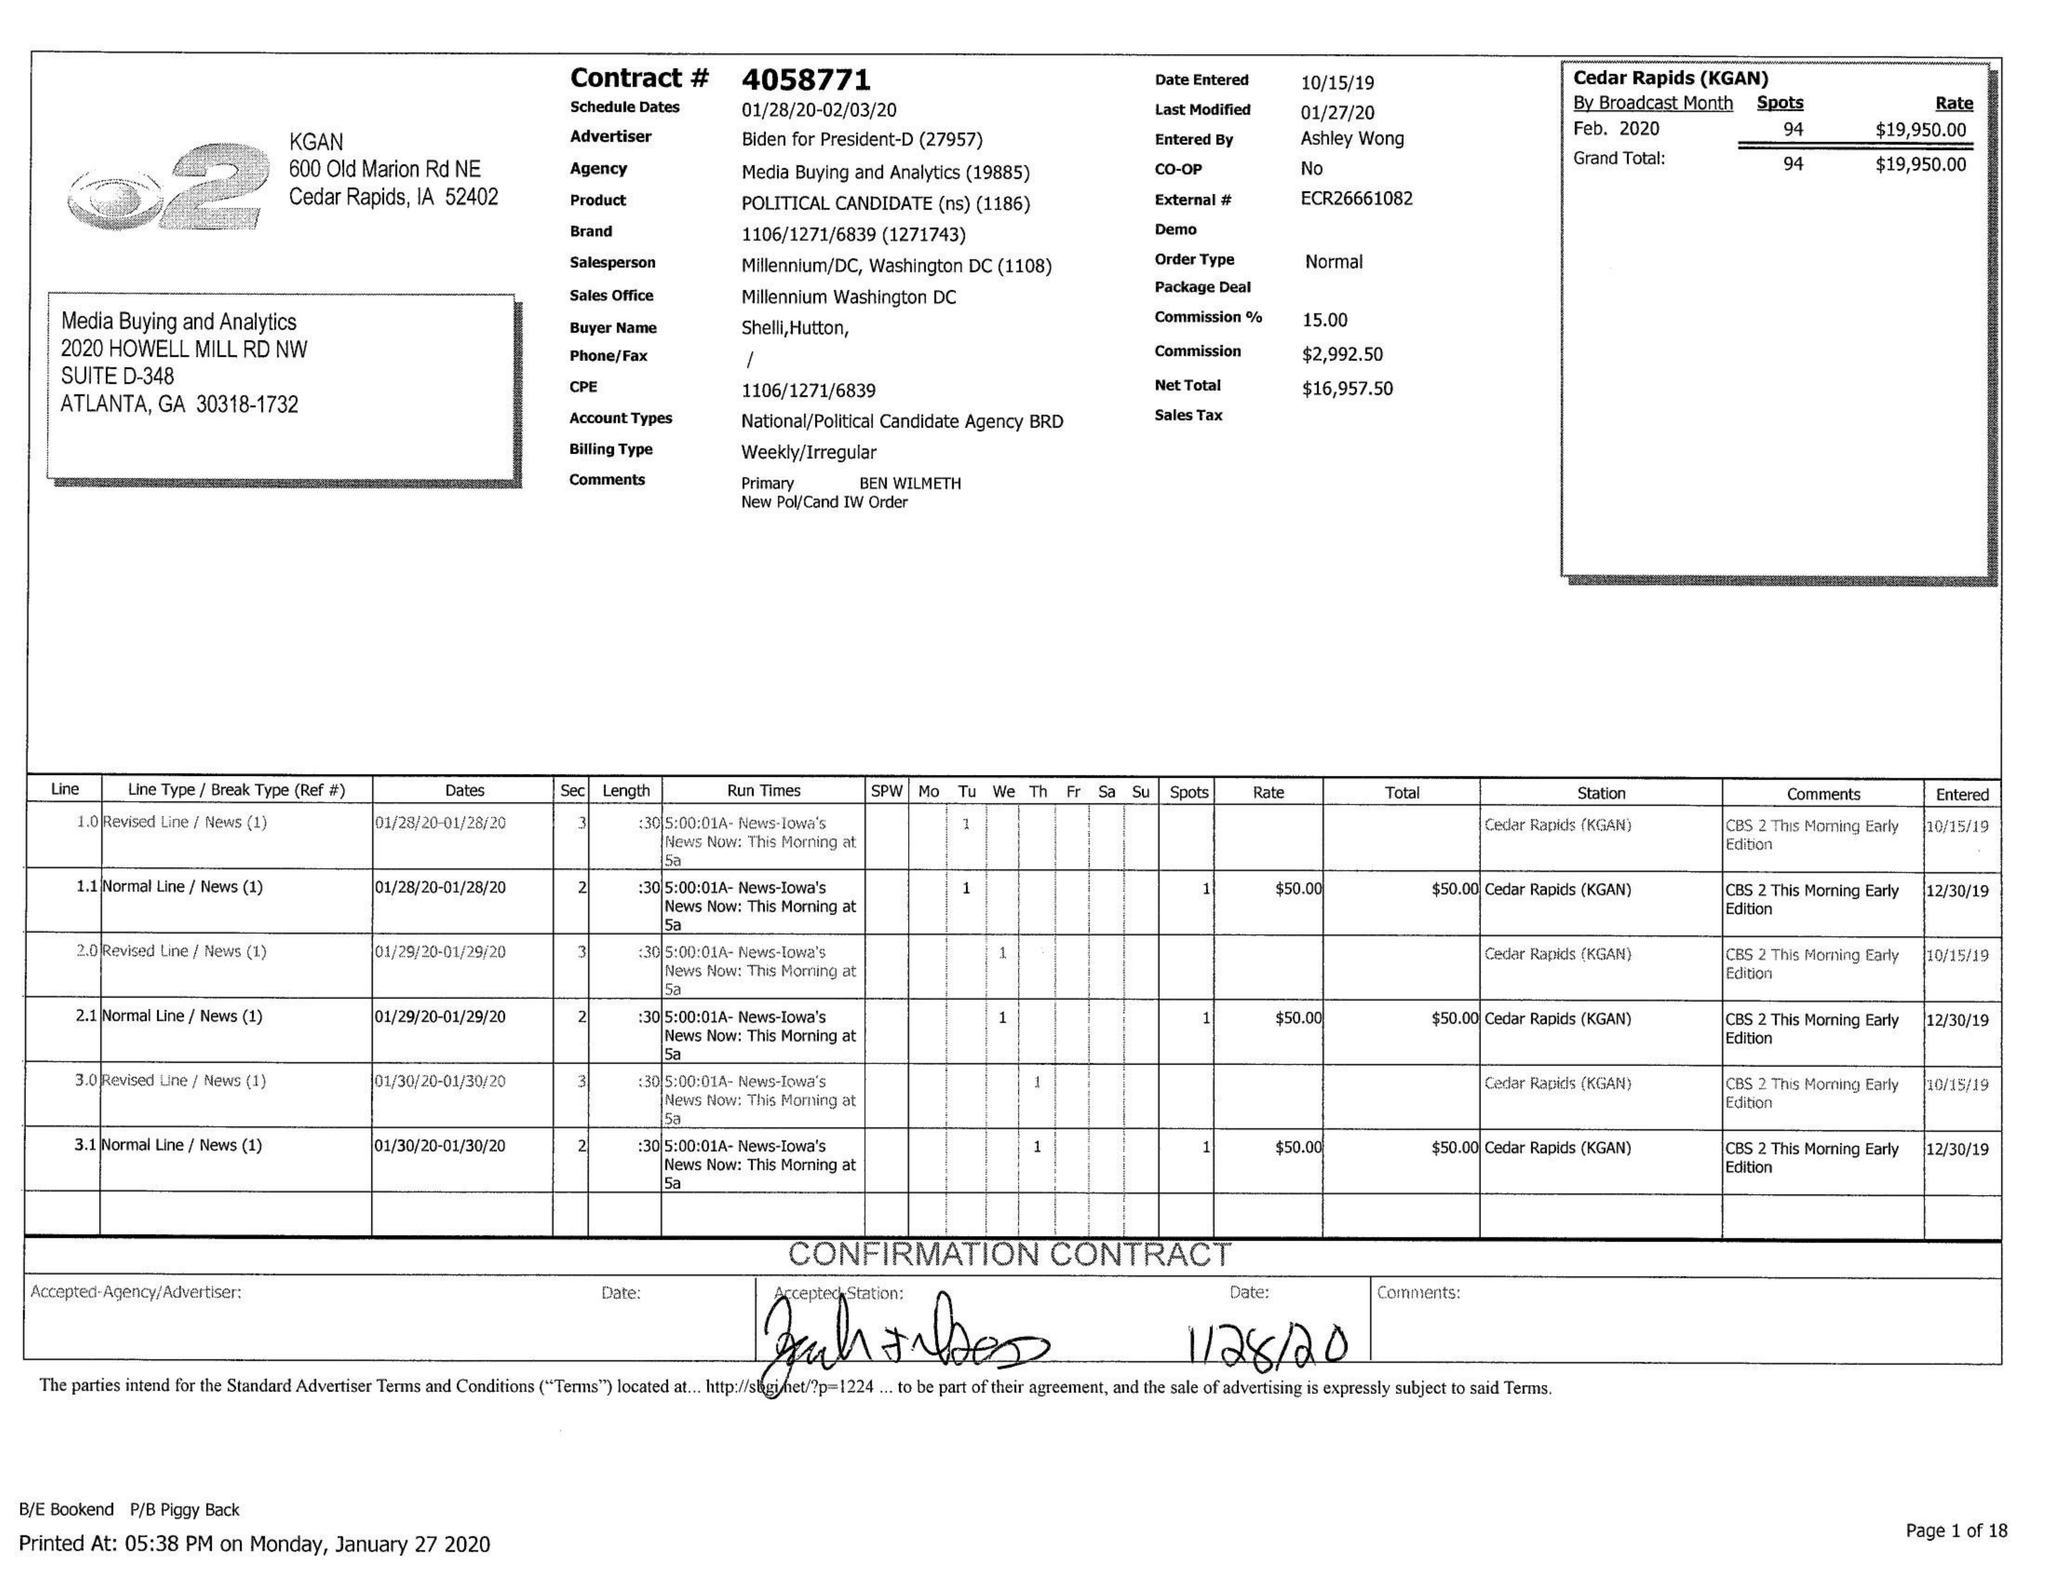What is the value for the contract_num?
Answer the question using a single word or phrase. 4058771 